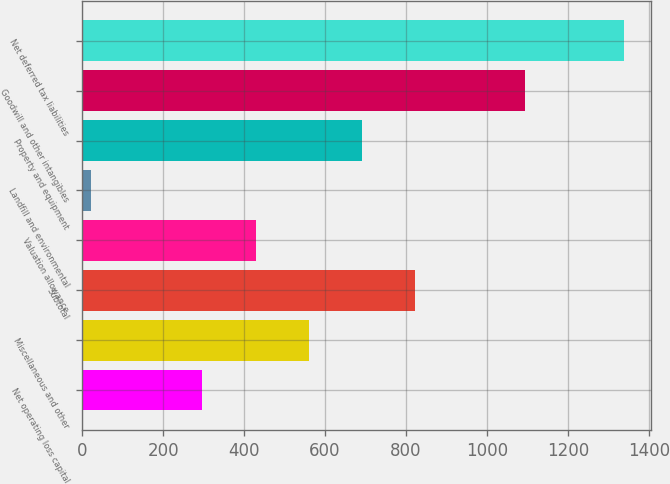<chart> <loc_0><loc_0><loc_500><loc_500><bar_chart><fcel>Net operating loss capital<fcel>Miscellaneous and other<fcel>Subtotal<fcel>Valuation allowance<fcel>Landfill and environmental<fcel>Property and equipment<fcel>Goodwill and other intangibles<fcel>Net deferred tax liabilities<nl><fcel>297<fcel>560.2<fcel>823.4<fcel>428.6<fcel>22<fcel>691.8<fcel>1095<fcel>1338<nl></chart> 